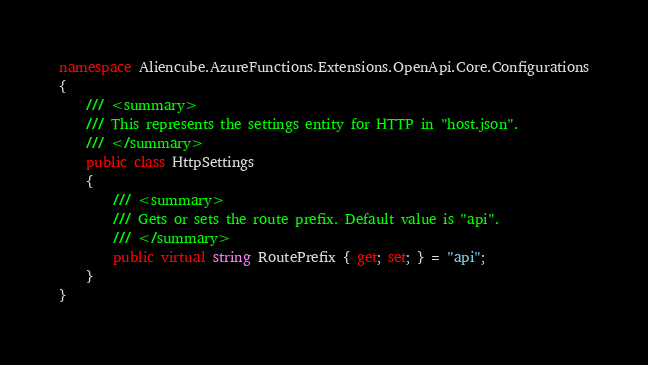<code> <loc_0><loc_0><loc_500><loc_500><_C#_>namespace Aliencube.AzureFunctions.Extensions.OpenApi.Core.Configurations
{
    /// <summary>
    /// This represents the settings entity for HTTP in "host.json".
    /// </summary>
    public class HttpSettings
    {
        /// <summary>
        /// Gets or sets the route prefix. Default value is "api".
        /// </summary>
        public virtual string RoutePrefix { get; set; } = "api";
    }
}
</code> 